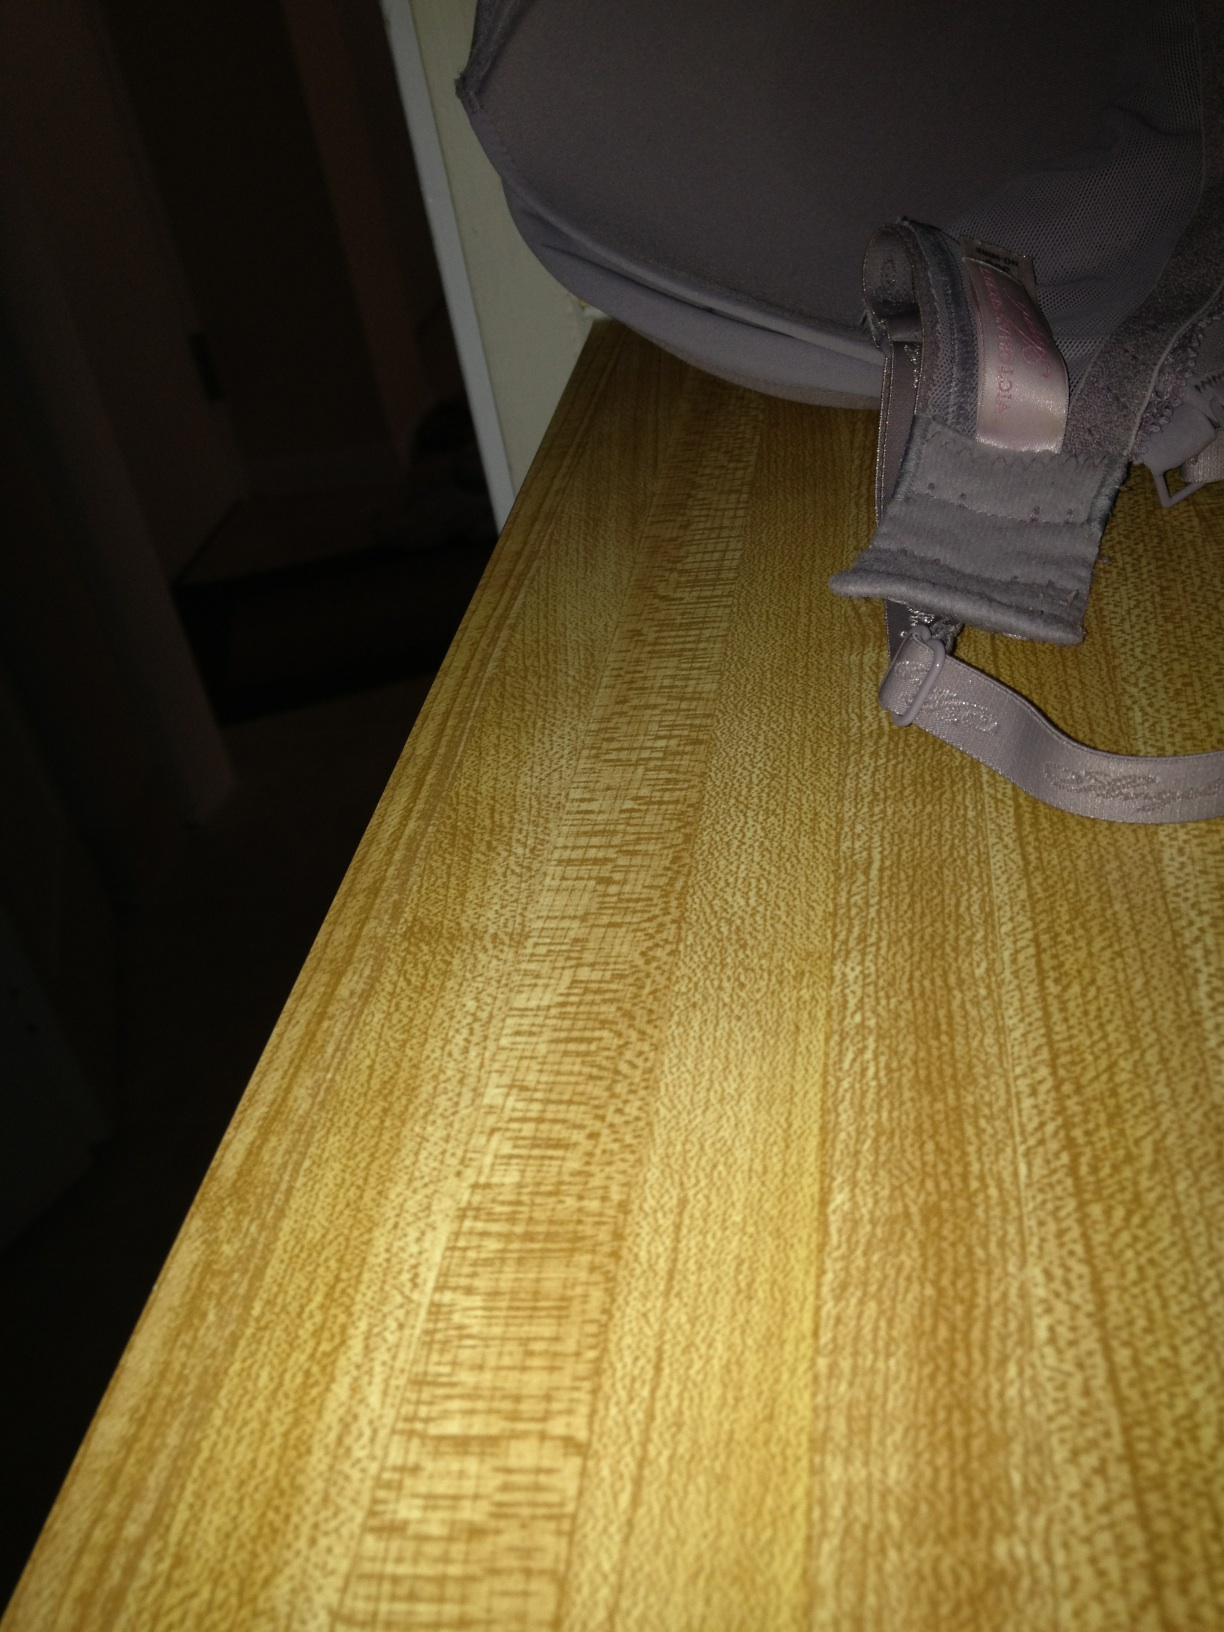What material is this undergarment made of? The undergarment appears to be made of a synthetic blend, likely including materials like nylon or polyester, which are common in stretchy and form-fitting garments such as bras. 